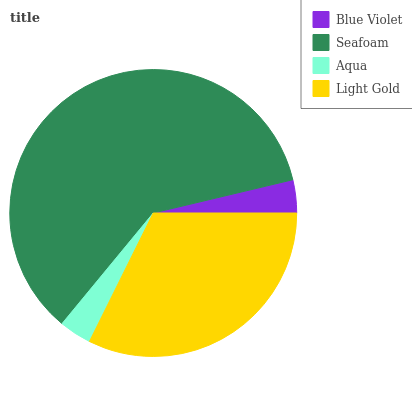Is Aqua the minimum?
Answer yes or no. Yes. Is Seafoam the maximum?
Answer yes or no. Yes. Is Seafoam the minimum?
Answer yes or no. No. Is Aqua the maximum?
Answer yes or no. No. Is Seafoam greater than Aqua?
Answer yes or no. Yes. Is Aqua less than Seafoam?
Answer yes or no. Yes. Is Aqua greater than Seafoam?
Answer yes or no. No. Is Seafoam less than Aqua?
Answer yes or no. No. Is Light Gold the high median?
Answer yes or no. Yes. Is Blue Violet the low median?
Answer yes or no. Yes. Is Aqua the high median?
Answer yes or no. No. Is Light Gold the low median?
Answer yes or no. No. 